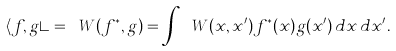Convert formula to latex. <formula><loc_0><loc_0><loc_500><loc_500>\langle f , g \rangle = \ W ( f ^ { * } , g ) = \int { \ W } ( x , x ^ { \prime } ) f ^ { * } ( x ) g ( x ^ { \prime } ) \, d x \, d x ^ { \prime } .</formula> 